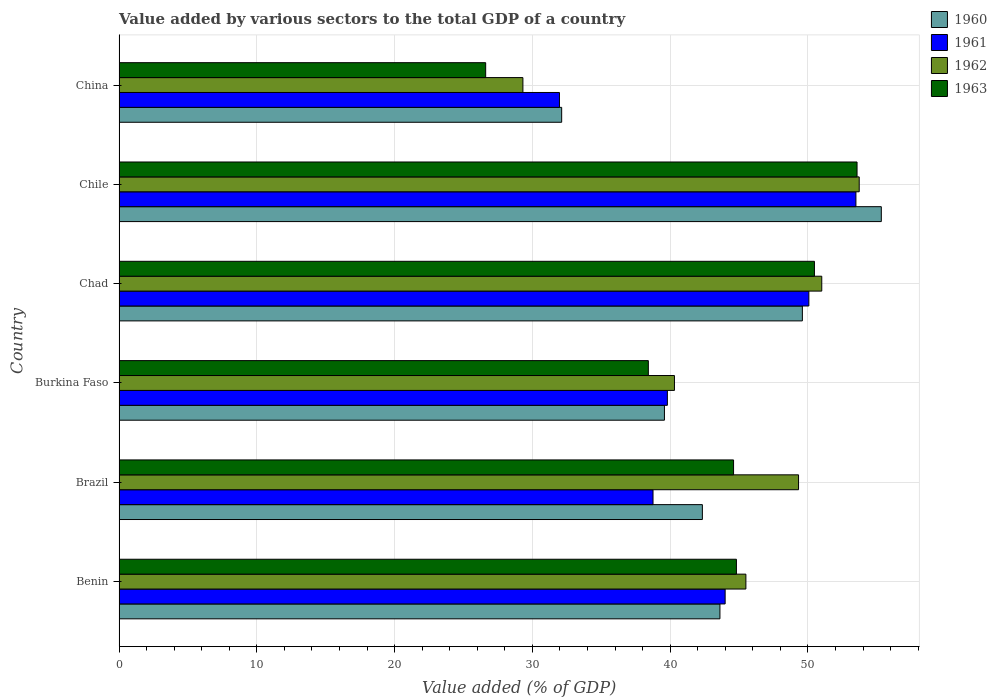How many groups of bars are there?
Keep it short and to the point. 6. Are the number of bars per tick equal to the number of legend labels?
Offer a very short reply. Yes. Are the number of bars on each tick of the Y-axis equal?
Provide a succinct answer. Yes. How many bars are there on the 4th tick from the top?
Provide a short and direct response. 4. What is the value added by various sectors to the total GDP in 1962 in Chad?
Keep it short and to the point. 51.01. Across all countries, what is the maximum value added by various sectors to the total GDP in 1962?
Your answer should be compact. 53.72. Across all countries, what is the minimum value added by various sectors to the total GDP in 1963?
Your answer should be very brief. 26.61. In which country was the value added by various sectors to the total GDP in 1963 maximum?
Ensure brevity in your answer.  Chile. What is the total value added by various sectors to the total GDP in 1960 in the graph?
Offer a terse response. 262.6. What is the difference between the value added by various sectors to the total GDP in 1960 in Chad and that in Chile?
Provide a short and direct response. -5.73. What is the difference between the value added by various sectors to the total GDP in 1961 in Brazil and the value added by various sectors to the total GDP in 1963 in Benin?
Ensure brevity in your answer.  -6.05. What is the average value added by various sectors to the total GDP in 1963 per country?
Give a very brief answer. 43.08. What is the difference between the value added by various sectors to the total GDP in 1960 and value added by various sectors to the total GDP in 1961 in Benin?
Make the answer very short. -0.38. In how many countries, is the value added by various sectors to the total GDP in 1963 greater than 28 %?
Ensure brevity in your answer.  5. What is the ratio of the value added by various sectors to the total GDP in 1961 in Burkina Faso to that in Chile?
Keep it short and to the point. 0.74. Is the difference between the value added by various sectors to the total GDP in 1960 in Chad and China greater than the difference between the value added by various sectors to the total GDP in 1961 in Chad and China?
Provide a succinct answer. No. What is the difference between the highest and the second highest value added by various sectors to the total GDP in 1960?
Provide a succinct answer. 5.73. What is the difference between the highest and the lowest value added by various sectors to the total GDP in 1962?
Provide a succinct answer. 24.41. In how many countries, is the value added by various sectors to the total GDP in 1961 greater than the average value added by various sectors to the total GDP in 1961 taken over all countries?
Your answer should be compact. 3. Is it the case that in every country, the sum of the value added by various sectors to the total GDP in 1960 and value added by various sectors to the total GDP in 1963 is greater than the value added by various sectors to the total GDP in 1962?
Make the answer very short. Yes. How many bars are there?
Offer a very short reply. 24. Are all the bars in the graph horizontal?
Ensure brevity in your answer.  Yes. How many countries are there in the graph?
Make the answer very short. 6. What is the difference between two consecutive major ticks on the X-axis?
Offer a terse response. 10. Does the graph contain grids?
Offer a very short reply. Yes. Where does the legend appear in the graph?
Give a very brief answer. Top right. What is the title of the graph?
Give a very brief answer. Value added by various sectors to the total GDP of a country. Does "1999" appear as one of the legend labels in the graph?
Your answer should be very brief. No. What is the label or title of the X-axis?
Ensure brevity in your answer.  Value added (% of GDP). What is the label or title of the Y-axis?
Your answer should be very brief. Country. What is the Value added (% of GDP) of 1960 in Benin?
Make the answer very short. 43.62. What is the Value added (% of GDP) of 1961 in Benin?
Provide a short and direct response. 43.99. What is the Value added (% of GDP) of 1962 in Benin?
Provide a short and direct response. 45.5. What is the Value added (% of GDP) in 1963 in Benin?
Your answer should be compact. 44.81. What is the Value added (% of GDP) in 1960 in Brazil?
Keep it short and to the point. 42.34. What is the Value added (% of GDP) in 1961 in Brazil?
Offer a terse response. 38.76. What is the Value added (% of GDP) in 1962 in Brazil?
Offer a very short reply. 49.32. What is the Value added (% of GDP) in 1963 in Brazil?
Offer a very short reply. 44.6. What is the Value added (% of GDP) in 1960 in Burkina Faso?
Your answer should be compact. 39.59. What is the Value added (% of GDP) of 1961 in Burkina Faso?
Give a very brief answer. 39.8. What is the Value added (% of GDP) of 1962 in Burkina Faso?
Your answer should be very brief. 40.31. What is the Value added (% of GDP) in 1963 in Burkina Faso?
Your answer should be very brief. 38.42. What is the Value added (% of GDP) of 1960 in Chad?
Make the answer very short. 49.6. What is the Value added (% of GDP) of 1961 in Chad?
Your answer should be compact. 50.07. What is the Value added (% of GDP) of 1962 in Chad?
Your response must be concise. 51.01. What is the Value added (% of GDP) in 1963 in Chad?
Offer a very short reply. 50.47. What is the Value added (% of GDP) in 1960 in Chile?
Keep it short and to the point. 55.33. What is the Value added (% of GDP) in 1961 in Chile?
Make the answer very short. 53.49. What is the Value added (% of GDP) in 1962 in Chile?
Your answer should be very brief. 53.72. What is the Value added (% of GDP) of 1963 in Chile?
Your answer should be compact. 53.57. What is the Value added (% of GDP) of 1960 in China?
Offer a very short reply. 32.13. What is the Value added (% of GDP) in 1961 in China?
Your answer should be compact. 31.97. What is the Value added (% of GDP) of 1962 in China?
Your answer should be very brief. 29.31. What is the Value added (% of GDP) in 1963 in China?
Provide a short and direct response. 26.61. Across all countries, what is the maximum Value added (% of GDP) of 1960?
Keep it short and to the point. 55.33. Across all countries, what is the maximum Value added (% of GDP) of 1961?
Offer a terse response. 53.49. Across all countries, what is the maximum Value added (% of GDP) in 1962?
Your answer should be very brief. 53.72. Across all countries, what is the maximum Value added (% of GDP) in 1963?
Keep it short and to the point. 53.57. Across all countries, what is the minimum Value added (% of GDP) in 1960?
Your answer should be very brief. 32.13. Across all countries, what is the minimum Value added (% of GDP) of 1961?
Provide a short and direct response. 31.97. Across all countries, what is the minimum Value added (% of GDP) in 1962?
Your response must be concise. 29.31. Across all countries, what is the minimum Value added (% of GDP) in 1963?
Give a very brief answer. 26.61. What is the total Value added (% of GDP) in 1960 in the graph?
Your answer should be compact. 262.6. What is the total Value added (% of GDP) in 1961 in the graph?
Your response must be concise. 258.07. What is the total Value added (% of GDP) of 1962 in the graph?
Your answer should be compact. 269.18. What is the total Value added (% of GDP) in 1963 in the graph?
Your answer should be compact. 258.49. What is the difference between the Value added (% of GDP) in 1960 in Benin and that in Brazil?
Your answer should be compact. 1.27. What is the difference between the Value added (% of GDP) in 1961 in Benin and that in Brazil?
Ensure brevity in your answer.  5.23. What is the difference between the Value added (% of GDP) in 1962 in Benin and that in Brazil?
Your answer should be very brief. -3.82. What is the difference between the Value added (% of GDP) in 1963 in Benin and that in Brazil?
Your response must be concise. 0.21. What is the difference between the Value added (% of GDP) of 1960 in Benin and that in Burkina Faso?
Give a very brief answer. 4.03. What is the difference between the Value added (% of GDP) in 1961 in Benin and that in Burkina Faso?
Offer a very short reply. 4.19. What is the difference between the Value added (% of GDP) of 1962 in Benin and that in Burkina Faso?
Your answer should be compact. 5.19. What is the difference between the Value added (% of GDP) of 1963 in Benin and that in Burkina Faso?
Ensure brevity in your answer.  6.39. What is the difference between the Value added (% of GDP) in 1960 in Benin and that in Chad?
Offer a very short reply. -5.98. What is the difference between the Value added (% of GDP) of 1961 in Benin and that in Chad?
Provide a succinct answer. -6.08. What is the difference between the Value added (% of GDP) of 1962 in Benin and that in Chad?
Make the answer very short. -5.51. What is the difference between the Value added (% of GDP) of 1963 in Benin and that in Chad?
Your answer should be very brief. -5.66. What is the difference between the Value added (% of GDP) in 1960 in Benin and that in Chile?
Your response must be concise. -11.71. What is the difference between the Value added (% of GDP) of 1961 in Benin and that in Chile?
Your answer should be very brief. -9.49. What is the difference between the Value added (% of GDP) of 1962 in Benin and that in Chile?
Your answer should be compact. -8.22. What is the difference between the Value added (% of GDP) of 1963 in Benin and that in Chile?
Make the answer very short. -8.75. What is the difference between the Value added (% of GDP) in 1960 in Benin and that in China?
Ensure brevity in your answer.  11.49. What is the difference between the Value added (% of GDP) in 1961 in Benin and that in China?
Ensure brevity in your answer.  12.03. What is the difference between the Value added (% of GDP) of 1962 in Benin and that in China?
Provide a short and direct response. 16.19. What is the difference between the Value added (% of GDP) of 1963 in Benin and that in China?
Ensure brevity in your answer.  18.2. What is the difference between the Value added (% of GDP) of 1960 in Brazil and that in Burkina Faso?
Ensure brevity in your answer.  2.75. What is the difference between the Value added (% of GDP) in 1961 in Brazil and that in Burkina Faso?
Keep it short and to the point. -1.04. What is the difference between the Value added (% of GDP) in 1962 in Brazil and that in Burkina Faso?
Keep it short and to the point. 9.01. What is the difference between the Value added (% of GDP) in 1963 in Brazil and that in Burkina Faso?
Your answer should be compact. 6.19. What is the difference between the Value added (% of GDP) of 1960 in Brazil and that in Chad?
Your answer should be very brief. -7.26. What is the difference between the Value added (% of GDP) in 1961 in Brazil and that in Chad?
Ensure brevity in your answer.  -11.31. What is the difference between the Value added (% of GDP) in 1962 in Brazil and that in Chad?
Offer a very short reply. -1.69. What is the difference between the Value added (% of GDP) in 1963 in Brazil and that in Chad?
Offer a terse response. -5.87. What is the difference between the Value added (% of GDP) of 1960 in Brazil and that in Chile?
Your response must be concise. -12.99. What is the difference between the Value added (% of GDP) of 1961 in Brazil and that in Chile?
Your answer should be very brief. -14.73. What is the difference between the Value added (% of GDP) of 1962 in Brazil and that in Chile?
Keep it short and to the point. -4.4. What is the difference between the Value added (% of GDP) in 1963 in Brazil and that in Chile?
Your answer should be very brief. -8.96. What is the difference between the Value added (% of GDP) in 1960 in Brazil and that in China?
Ensure brevity in your answer.  10.21. What is the difference between the Value added (% of GDP) of 1961 in Brazil and that in China?
Your answer should be very brief. 6.79. What is the difference between the Value added (% of GDP) in 1962 in Brazil and that in China?
Ensure brevity in your answer.  20.01. What is the difference between the Value added (% of GDP) in 1963 in Brazil and that in China?
Make the answer very short. 17.99. What is the difference between the Value added (% of GDP) of 1960 in Burkina Faso and that in Chad?
Provide a succinct answer. -10.01. What is the difference between the Value added (% of GDP) of 1961 in Burkina Faso and that in Chad?
Give a very brief answer. -10.27. What is the difference between the Value added (% of GDP) in 1962 in Burkina Faso and that in Chad?
Offer a very short reply. -10.69. What is the difference between the Value added (% of GDP) in 1963 in Burkina Faso and that in Chad?
Offer a very short reply. -12.06. What is the difference between the Value added (% of GDP) of 1960 in Burkina Faso and that in Chile?
Your answer should be very brief. -15.74. What is the difference between the Value added (% of GDP) in 1961 in Burkina Faso and that in Chile?
Your response must be concise. -13.69. What is the difference between the Value added (% of GDP) in 1962 in Burkina Faso and that in Chile?
Give a very brief answer. -13.41. What is the difference between the Value added (% of GDP) of 1963 in Burkina Faso and that in Chile?
Ensure brevity in your answer.  -15.15. What is the difference between the Value added (% of GDP) in 1960 in Burkina Faso and that in China?
Give a very brief answer. 7.46. What is the difference between the Value added (% of GDP) in 1961 in Burkina Faso and that in China?
Provide a short and direct response. 7.83. What is the difference between the Value added (% of GDP) in 1962 in Burkina Faso and that in China?
Provide a short and direct response. 11. What is the difference between the Value added (% of GDP) of 1963 in Burkina Faso and that in China?
Provide a succinct answer. 11.81. What is the difference between the Value added (% of GDP) in 1960 in Chad and that in Chile?
Your answer should be compact. -5.73. What is the difference between the Value added (% of GDP) in 1961 in Chad and that in Chile?
Your response must be concise. -3.42. What is the difference between the Value added (% of GDP) in 1962 in Chad and that in Chile?
Ensure brevity in your answer.  -2.72. What is the difference between the Value added (% of GDP) in 1963 in Chad and that in Chile?
Your response must be concise. -3.09. What is the difference between the Value added (% of GDP) of 1960 in Chad and that in China?
Your answer should be compact. 17.47. What is the difference between the Value added (% of GDP) in 1961 in Chad and that in China?
Make the answer very short. 18.1. What is the difference between the Value added (% of GDP) in 1962 in Chad and that in China?
Give a very brief answer. 21.69. What is the difference between the Value added (% of GDP) in 1963 in Chad and that in China?
Make the answer very short. 23.86. What is the difference between the Value added (% of GDP) in 1960 in Chile and that in China?
Your response must be concise. 23.2. What is the difference between the Value added (% of GDP) of 1961 in Chile and that in China?
Your answer should be very brief. 21.52. What is the difference between the Value added (% of GDP) of 1962 in Chile and that in China?
Make the answer very short. 24.41. What is the difference between the Value added (% of GDP) of 1963 in Chile and that in China?
Ensure brevity in your answer.  26.96. What is the difference between the Value added (% of GDP) of 1960 in Benin and the Value added (% of GDP) of 1961 in Brazil?
Provide a succinct answer. 4.86. What is the difference between the Value added (% of GDP) in 1960 in Benin and the Value added (% of GDP) in 1962 in Brazil?
Your response must be concise. -5.71. What is the difference between the Value added (% of GDP) in 1960 in Benin and the Value added (% of GDP) in 1963 in Brazil?
Ensure brevity in your answer.  -0.99. What is the difference between the Value added (% of GDP) in 1961 in Benin and the Value added (% of GDP) in 1962 in Brazil?
Keep it short and to the point. -5.33. What is the difference between the Value added (% of GDP) of 1961 in Benin and the Value added (% of GDP) of 1963 in Brazil?
Your answer should be very brief. -0.61. What is the difference between the Value added (% of GDP) of 1962 in Benin and the Value added (% of GDP) of 1963 in Brazil?
Provide a short and direct response. 0.89. What is the difference between the Value added (% of GDP) in 1960 in Benin and the Value added (% of GDP) in 1961 in Burkina Faso?
Your answer should be compact. 3.82. What is the difference between the Value added (% of GDP) of 1960 in Benin and the Value added (% of GDP) of 1962 in Burkina Faso?
Keep it short and to the point. 3.3. What is the difference between the Value added (% of GDP) of 1960 in Benin and the Value added (% of GDP) of 1963 in Burkina Faso?
Give a very brief answer. 5.2. What is the difference between the Value added (% of GDP) of 1961 in Benin and the Value added (% of GDP) of 1962 in Burkina Faso?
Provide a succinct answer. 3.68. What is the difference between the Value added (% of GDP) of 1961 in Benin and the Value added (% of GDP) of 1963 in Burkina Faso?
Keep it short and to the point. 5.57. What is the difference between the Value added (% of GDP) of 1962 in Benin and the Value added (% of GDP) of 1963 in Burkina Faso?
Ensure brevity in your answer.  7.08. What is the difference between the Value added (% of GDP) of 1960 in Benin and the Value added (% of GDP) of 1961 in Chad?
Your response must be concise. -6.45. What is the difference between the Value added (% of GDP) of 1960 in Benin and the Value added (% of GDP) of 1962 in Chad?
Provide a short and direct response. -7.39. What is the difference between the Value added (% of GDP) of 1960 in Benin and the Value added (% of GDP) of 1963 in Chad?
Your answer should be very brief. -6.86. What is the difference between the Value added (% of GDP) of 1961 in Benin and the Value added (% of GDP) of 1962 in Chad?
Your answer should be compact. -7.01. What is the difference between the Value added (% of GDP) of 1961 in Benin and the Value added (% of GDP) of 1963 in Chad?
Keep it short and to the point. -6.48. What is the difference between the Value added (% of GDP) in 1962 in Benin and the Value added (% of GDP) in 1963 in Chad?
Ensure brevity in your answer.  -4.98. What is the difference between the Value added (% of GDP) of 1960 in Benin and the Value added (% of GDP) of 1961 in Chile?
Make the answer very short. -9.87. What is the difference between the Value added (% of GDP) of 1960 in Benin and the Value added (% of GDP) of 1962 in Chile?
Keep it short and to the point. -10.11. What is the difference between the Value added (% of GDP) in 1960 in Benin and the Value added (% of GDP) in 1963 in Chile?
Offer a very short reply. -9.95. What is the difference between the Value added (% of GDP) of 1961 in Benin and the Value added (% of GDP) of 1962 in Chile?
Your answer should be compact. -9.73. What is the difference between the Value added (% of GDP) of 1961 in Benin and the Value added (% of GDP) of 1963 in Chile?
Your response must be concise. -9.57. What is the difference between the Value added (% of GDP) in 1962 in Benin and the Value added (% of GDP) in 1963 in Chile?
Keep it short and to the point. -8.07. What is the difference between the Value added (% of GDP) of 1960 in Benin and the Value added (% of GDP) of 1961 in China?
Your response must be concise. 11.65. What is the difference between the Value added (% of GDP) of 1960 in Benin and the Value added (% of GDP) of 1962 in China?
Give a very brief answer. 14.3. What is the difference between the Value added (% of GDP) in 1960 in Benin and the Value added (% of GDP) in 1963 in China?
Give a very brief answer. 17. What is the difference between the Value added (% of GDP) in 1961 in Benin and the Value added (% of GDP) in 1962 in China?
Your response must be concise. 14.68. What is the difference between the Value added (% of GDP) of 1961 in Benin and the Value added (% of GDP) of 1963 in China?
Your response must be concise. 17.38. What is the difference between the Value added (% of GDP) in 1962 in Benin and the Value added (% of GDP) in 1963 in China?
Your answer should be compact. 18.89. What is the difference between the Value added (% of GDP) of 1960 in Brazil and the Value added (% of GDP) of 1961 in Burkina Faso?
Your response must be concise. 2.54. What is the difference between the Value added (% of GDP) in 1960 in Brazil and the Value added (% of GDP) in 1962 in Burkina Faso?
Make the answer very short. 2.03. What is the difference between the Value added (% of GDP) in 1960 in Brazil and the Value added (% of GDP) in 1963 in Burkina Faso?
Give a very brief answer. 3.92. What is the difference between the Value added (% of GDP) in 1961 in Brazil and the Value added (% of GDP) in 1962 in Burkina Faso?
Your response must be concise. -1.55. What is the difference between the Value added (% of GDP) of 1961 in Brazil and the Value added (% of GDP) of 1963 in Burkina Faso?
Ensure brevity in your answer.  0.34. What is the difference between the Value added (% of GDP) of 1962 in Brazil and the Value added (% of GDP) of 1963 in Burkina Faso?
Keep it short and to the point. 10.9. What is the difference between the Value added (% of GDP) in 1960 in Brazil and the Value added (% of GDP) in 1961 in Chad?
Ensure brevity in your answer.  -7.73. What is the difference between the Value added (% of GDP) of 1960 in Brazil and the Value added (% of GDP) of 1962 in Chad?
Give a very brief answer. -8.67. What is the difference between the Value added (% of GDP) in 1960 in Brazil and the Value added (% of GDP) in 1963 in Chad?
Ensure brevity in your answer.  -8.13. What is the difference between the Value added (% of GDP) in 1961 in Brazil and the Value added (% of GDP) in 1962 in Chad?
Your answer should be compact. -12.25. What is the difference between the Value added (% of GDP) in 1961 in Brazil and the Value added (% of GDP) in 1963 in Chad?
Give a very brief answer. -11.72. What is the difference between the Value added (% of GDP) of 1962 in Brazil and the Value added (% of GDP) of 1963 in Chad?
Your response must be concise. -1.15. What is the difference between the Value added (% of GDP) in 1960 in Brazil and the Value added (% of GDP) in 1961 in Chile?
Your response must be concise. -11.14. What is the difference between the Value added (% of GDP) of 1960 in Brazil and the Value added (% of GDP) of 1962 in Chile?
Provide a short and direct response. -11.38. What is the difference between the Value added (% of GDP) of 1960 in Brazil and the Value added (% of GDP) of 1963 in Chile?
Give a very brief answer. -11.23. What is the difference between the Value added (% of GDP) in 1961 in Brazil and the Value added (% of GDP) in 1962 in Chile?
Your answer should be compact. -14.97. What is the difference between the Value added (% of GDP) in 1961 in Brazil and the Value added (% of GDP) in 1963 in Chile?
Your answer should be compact. -14.81. What is the difference between the Value added (% of GDP) in 1962 in Brazil and the Value added (% of GDP) in 1963 in Chile?
Your answer should be compact. -4.25. What is the difference between the Value added (% of GDP) in 1960 in Brazil and the Value added (% of GDP) in 1961 in China?
Your response must be concise. 10.37. What is the difference between the Value added (% of GDP) in 1960 in Brazil and the Value added (% of GDP) in 1962 in China?
Offer a very short reply. 13.03. What is the difference between the Value added (% of GDP) of 1960 in Brazil and the Value added (% of GDP) of 1963 in China?
Keep it short and to the point. 15.73. What is the difference between the Value added (% of GDP) of 1961 in Brazil and the Value added (% of GDP) of 1962 in China?
Ensure brevity in your answer.  9.44. What is the difference between the Value added (% of GDP) of 1961 in Brazil and the Value added (% of GDP) of 1963 in China?
Provide a succinct answer. 12.15. What is the difference between the Value added (% of GDP) of 1962 in Brazil and the Value added (% of GDP) of 1963 in China?
Provide a succinct answer. 22.71. What is the difference between the Value added (% of GDP) of 1960 in Burkina Faso and the Value added (% of GDP) of 1961 in Chad?
Your answer should be compact. -10.48. What is the difference between the Value added (% of GDP) in 1960 in Burkina Faso and the Value added (% of GDP) in 1962 in Chad?
Keep it short and to the point. -11.42. What is the difference between the Value added (% of GDP) in 1960 in Burkina Faso and the Value added (% of GDP) in 1963 in Chad?
Give a very brief answer. -10.89. What is the difference between the Value added (% of GDP) of 1961 in Burkina Faso and the Value added (% of GDP) of 1962 in Chad?
Offer a terse response. -11.21. What is the difference between the Value added (% of GDP) of 1961 in Burkina Faso and the Value added (% of GDP) of 1963 in Chad?
Your answer should be very brief. -10.68. What is the difference between the Value added (% of GDP) in 1962 in Burkina Faso and the Value added (% of GDP) in 1963 in Chad?
Offer a terse response. -10.16. What is the difference between the Value added (% of GDP) in 1960 in Burkina Faso and the Value added (% of GDP) in 1961 in Chile?
Give a very brief answer. -13.9. What is the difference between the Value added (% of GDP) in 1960 in Burkina Faso and the Value added (% of GDP) in 1962 in Chile?
Provide a succinct answer. -14.14. What is the difference between the Value added (% of GDP) of 1960 in Burkina Faso and the Value added (% of GDP) of 1963 in Chile?
Your answer should be compact. -13.98. What is the difference between the Value added (% of GDP) of 1961 in Burkina Faso and the Value added (% of GDP) of 1962 in Chile?
Offer a very short reply. -13.92. What is the difference between the Value added (% of GDP) of 1961 in Burkina Faso and the Value added (% of GDP) of 1963 in Chile?
Keep it short and to the point. -13.77. What is the difference between the Value added (% of GDP) of 1962 in Burkina Faso and the Value added (% of GDP) of 1963 in Chile?
Offer a terse response. -13.25. What is the difference between the Value added (% of GDP) of 1960 in Burkina Faso and the Value added (% of GDP) of 1961 in China?
Keep it short and to the point. 7.62. What is the difference between the Value added (% of GDP) of 1960 in Burkina Faso and the Value added (% of GDP) of 1962 in China?
Your answer should be compact. 10.27. What is the difference between the Value added (% of GDP) in 1960 in Burkina Faso and the Value added (% of GDP) in 1963 in China?
Provide a succinct answer. 12.97. What is the difference between the Value added (% of GDP) in 1961 in Burkina Faso and the Value added (% of GDP) in 1962 in China?
Your answer should be very brief. 10.49. What is the difference between the Value added (% of GDP) in 1961 in Burkina Faso and the Value added (% of GDP) in 1963 in China?
Offer a very short reply. 13.19. What is the difference between the Value added (% of GDP) of 1962 in Burkina Faso and the Value added (% of GDP) of 1963 in China?
Provide a succinct answer. 13.7. What is the difference between the Value added (% of GDP) in 1960 in Chad and the Value added (% of GDP) in 1961 in Chile?
Your answer should be compact. -3.89. What is the difference between the Value added (% of GDP) in 1960 in Chad and the Value added (% of GDP) in 1962 in Chile?
Provide a succinct answer. -4.13. What is the difference between the Value added (% of GDP) in 1960 in Chad and the Value added (% of GDP) in 1963 in Chile?
Keep it short and to the point. -3.97. What is the difference between the Value added (% of GDP) of 1961 in Chad and the Value added (% of GDP) of 1962 in Chile?
Your answer should be compact. -3.66. What is the difference between the Value added (% of GDP) of 1961 in Chad and the Value added (% of GDP) of 1963 in Chile?
Ensure brevity in your answer.  -3.5. What is the difference between the Value added (% of GDP) in 1962 in Chad and the Value added (% of GDP) in 1963 in Chile?
Ensure brevity in your answer.  -2.56. What is the difference between the Value added (% of GDP) in 1960 in Chad and the Value added (% of GDP) in 1961 in China?
Your answer should be compact. 17.63. What is the difference between the Value added (% of GDP) of 1960 in Chad and the Value added (% of GDP) of 1962 in China?
Offer a terse response. 20.29. What is the difference between the Value added (% of GDP) in 1960 in Chad and the Value added (% of GDP) in 1963 in China?
Your answer should be compact. 22.99. What is the difference between the Value added (% of GDP) in 1961 in Chad and the Value added (% of GDP) in 1962 in China?
Offer a very short reply. 20.76. What is the difference between the Value added (% of GDP) in 1961 in Chad and the Value added (% of GDP) in 1963 in China?
Keep it short and to the point. 23.46. What is the difference between the Value added (% of GDP) of 1962 in Chad and the Value added (% of GDP) of 1963 in China?
Your answer should be compact. 24.39. What is the difference between the Value added (% of GDP) of 1960 in Chile and the Value added (% of GDP) of 1961 in China?
Make the answer very short. 23.36. What is the difference between the Value added (% of GDP) of 1960 in Chile and the Value added (% of GDP) of 1962 in China?
Keep it short and to the point. 26.02. What is the difference between the Value added (% of GDP) in 1960 in Chile and the Value added (% of GDP) in 1963 in China?
Keep it short and to the point. 28.72. What is the difference between the Value added (% of GDP) in 1961 in Chile and the Value added (% of GDP) in 1962 in China?
Give a very brief answer. 24.17. What is the difference between the Value added (% of GDP) in 1961 in Chile and the Value added (% of GDP) in 1963 in China?
Ensure brevity in your answer.  26.87. What is the difference between the Value added (% of GDP) in 1962 in Chile and the Value added (% of GDP) in 1963 in China?
Give a very brief answer. 27.11. What is the average Value added (% of GDP) in 1960 per country?
Your answer should be compact. 43.77. What is the average Value added (% of GDP) of 1961 per country?
Your answer should be compact. 43.01. What is the average Value added (% of GDP) in 1962 per country?
Make the answer very short. 44.86. What is the average Value added (% of GDP) in 1963 per country?
Your answer should be compact. 43.08. What is the difference between the Value added (% of GDP) of 1960 and Value added (% of GDP) of 1961 in Benin?
Keep it short and to the point. -0.38. What is the difference between the Value added (% of GDP) in 1960 and Value added (% of GDP) in 1962 in Benin?
Make the answer very short. -1.88. What is the difference between the Value added (% of GDP) in 1960 and Value added (% of GDP) in 1963 in Benin?
Provide a short and direct response. -1.2. What is the difference between the Value added (% of GDP) in 1961 and Value added (% of GDP) in 1962 in Benin?
Provide a short and direct response. -1.51. What is the difference between the Value added (% of GDP) in 1961 and Value added (% of GDP) in 1963 in Benin?
Ensure brevity in your answer.  -0.82. What is the difference between the Value added (% of GDP) in 1962 and Value added (% of GDP) in 1963 in Benin?
Offer a terse response. 0.69. What is the difference between the Value added (% of GDP) of 1960 and Value added (% of GDP) of 1961 in Brazil?
Offer a very short reply. 3.58. What is the difference between the Value added (% of GDP) in 1960 and Value added (% of GDP) in 1962 in Brazil?
Your answer should be compact. -6.98. What is the difference between the Value added (% of GDP) of 1960 and Value added (% of GDP) of 1963 in Brazil?
Offer a very short reply. -2.26. What is the difference between the Value added (% of GDP) of 1961 and Value added (% of GDP) of 1962 in Brazil?
Make the answer very short. -10.56. What is the difference between the Value added (% of GDP) of 1961 and Value added (% of GDP) of 1963 in Brazil?
Your response must be concise. -5.85. What is the difference between the Value added (% of GDP) of 1962 and Value added (% of GDP) of 1963 in Brazil?
Keep it short and to the point. 4.72. What is the difference between the Value added (% of GDP) of 1960 and Value added (% of GDP) of 1961 in Burkina Faso?
Ensure brevity in your answer.  -0.21. What is the difference between the Value added (% of GDP) in 1960 and Value added (% of GDP) in 1962 in Burkina Faso?
Your answer should be compact. -0.73. What is the difference between the Value added (% of GDP) in 1960 and Value added (% of GDP) in 1963 in Burkina Faso?
Give a very brief answer. 1.17. What is the difference between the Value added (% of GDP) in 1961 and Value added (% of GDP) in 1962 in Burkina Faso?
Offer a terse response. -0.51. What is the difference between the Value added (% of GDP) in 1961 and Value added (% of GDP) in 1963 in Burkina Faso?
Your response must be concise. 1.38. What is the difference between the Value added (% of GDP) in 1962 and Value added (% of GDP) in 1963 in Burkina Faso?
Make the answer very short. 1.89. What is the difference between the Value added (% of GDP) in 1960 and Value added (% of GDP) in 1961 in Chad?
Keep it short and to the point. -0.47. What is the difference between the Value added (% of GDP) in 1960 and Value added (% of GDP) in 1962 in Chad?
Your answer should be compact. -1.41. What is the difference between the Value added (% of GDP) in 1960 and Value added (% of GDP) in 1963 in Chad?
Ensure brevity in your answer.  -0.88. What is the difference between the Value added (% of GDP) in 1961 and Value added (% of GDP) in 1962 in Chad?
Your answer should be compact. -0.94. What is the difference between the Value added (% of GDP) of 1961 and Value added (% of GDP) of 1963 in Chad?
Offer a terse response. -0.41. What is the difference between the Value added (% of GDP) of 1962 and Value added (% of GDP) of 1963 in Chad?
Your answer should be very brief. 0.53. What is the difference between the Value added (% of GDP) in 1960 and Value added (% of GDP) in 1961 in Chile?
Make the answer very short. 1.84. What is the difference between the Value added (% of GDP) of 1960 and Value added (% of GDP) of 1962 in Chile?
Provide a short and direct response. 1.6. What is the difference between the Value added (% of GDP) of 1960 and Value added (% of GDP) of 1963 in Chile?
Give a very brief answer. 1.76. What is the difference between the Value added (% of GDP) of 1961 and Value added (% of GDP) of 1962 in Chile?
Provide a succinct answer. -0.24. What is the difference between the Value added (% of GDP) in 1961 and Value added (% of GDP) in 1963 in Chile?
Provide a short and direct response. -0.08. What is the difference between the Value added (% of GDP) of 1962 and Value added (% of GDP) of 1963 in Chile?
Offer a terse response. 0.16. What is the difference between the Value added (% of GDP) in 1960 and Value added (% of GDP) in 1961 in China?
Offer a very short reply. 0.16. What is the difference between the Value added (% of GDP) of 1960 and Value added (% of GDP) of 1962 in China?
Offer a terse response. 2.81. What is the difference between the Value added (% of GDP) of 1960 and Value added (% of GDP) of 1963 in China?
Offer a terse response. 5.52. What is the difference between the Value added (% of GDP) of 1961 and Value added (% of GDP) of 1962 in China?
Make the answer very short. 2.65. What is the difference between the Value added (% of GDP) of 1961 and Value added (% of GDP) of 1963 in China?
Your answer should be very brief. 5.36. What is the difference between the Value added (% of GDP) in 1962 and Value added (% of GDP) in 1963 in China?
Make the answer very short. 2.7. What is the ratio of the Value added (% of GDP) of 1960 in Benin to that in Brazil?
Provide a succinct answer. 1.03. What is the ratio of the Value added (% of GDP) of 1961 in Benin to that in Brazil?
Keep it short and to the point. 1.14. What is the ratio of the Value added (% of GDP) in 1962 in Benin to that in Brazil?
Keep it short and to the point. 0.92. What is the ratio of the Value added (% of GDP) in 1960 in Benin to that in Burkina Faso?
Your response must be concise. 1.1. What is the ratio of the Value added (% of GDP) of 1961 in Benin to that in Burkina Faso?
Keep it short and to the point. 1.11. What is the ratio of the Value added (% of GDP) of 1962 in Benin to that in Burkina Faso?
Offer a terse response. 1.13. What is the ratio of the Value added (% of GDP) in 1963 in Benin to that in Burkina Faso?
Provide a short and direct response. 1.17. What is the ratio of the Value added (% of GDP) of 1960 in Benin to that in Chad?
Your answer should be compact. 0.88. What is the ratio of the Value added (% of GDP) of 1961 in Benin to that in Chad?
Offer a very short reply. 0.88. What is the ratio of the Value added (% of GDP) in 1962 in Benin to that in Chad?
Your answer should be compact. 0.89. What is the ratio of the Value added (% of GDP) in 1963 in Benin to that in Chad?
Provide a succinct answer. 0.89. What is the ratio of the Value added (% of GDP) of 1960 in Benin to that in Chile?
Provide a short and direct response. 0.79. What is the ratio of the Value added (% of GDP) of 1961 in Benin to that in Chile?
Keep it short and to the point. 0.82. What is the ratio of the Value added (% of GDP) in 1962 in Benin to that in Chile?
Provide a short and direct response. 0.85. What is the ratio of the Value added (% of GDP) in 1963 in Benin to that in Chile?
Offer a terse response. 0.84. What is the ratio of the Value added (% of GDP) of 1960 in Benin to that in China?
Offer a terse response. 1.36. What is the ratio of the Value added (% of GDP) in 1961 in Benin to that in China?
Offer a terse response. 1.38. What is the ratio of the Value added (% of GDP) of 1962 in Benin to that in China?
Make the answer very short. 1.55. What is the ratio of the Value added (% of GDP) in 1963 in Benin to that in China?
Give a very brief answer. 1.68. What is the ratio of the Value added (% of GDP) of 1960 in Brazil to that in Burkina Faso?
Ensure brevity in your answer.  1.07. What is the ratio of the Value added (% of GDP) of 1961 in Brazil to that in Burkina Faso?
Provide a succinct answer. 0.97. What is the ratio of the Value added (% of GDP) in 1962 in Brazil to that in Burkina Faso?
Make the answer very short. 1.22. What is the ratio of the Value added (% of GDP) of 1963 in Brazil to that in Burkina Faso?
Provide a short and direct response. 1.16. What is the ratio of the Value added (% of GDP) in 1960 in Brazil to that in Chad?
Ensure brevity in your answer.  0.85. What is the ratio of the Value added (% of GDP) in 1961 in Brazil to that in Chad?
Offer a terse response. 0.77. What is the ratio of the Value added (% of GDP) in 1963 in Brazil to that in Chad?
Ensure brevity in your answer.  0.88. What is the ratio of the Value added (% of GDP) in 1960 in Brazil to that in Chile?
Ensure brevity in your answer.  0.77. What is the ratio of the Value added (% of GDP) in 1961 in Brazil to that in Chile?
Your answer should be very brief. 0.72. What is the ratio of the Value added (% of GDP) in 1962 in Brazil to that in Chile?
Make the answer very short. 0.92. What is the ratio of the Value added (% of GDP) in 1963 in Brazil to that in Chile?
Make the answer very short. 0.83. What is the ratio of the Value added (% of GDP) of 1960 in Brazil to that in China?
Offer a terse response. 1.32. What is the ratio of the Value added (% of GDP) of 1961 in Brazil to that in China?
Your answer should be compact. 1.21. What is the ratio of the Value added (% of GDP) of 1962 in Brazil to that in China?
Offer a terse response. 1.68. What is the ratio of the Value added (% of GDP) of 1963 in Brazil to that in China?
Provide a succinct answer. 1.68. What is the ratio of the Value added (% of GDP) of 1960 in Burkina Faso to that in Chad?
Keep it short and to the point. 0.8. What is the ratio of the Value added (% of GDP) of 1961 in Burkina Faso to that in Chad?
Provide a short and direct response. 0.79. What is the ratio of the Value added (% of GDP) in 1962 in Burkina Faso to that in Chad?
Give a very brief answer. 0.79. What is the ratio of the Value added (% of GDP) of 1963 in Burkina Faso to that in Chad?
Give a very brief answer. 0.76. What is the ratio of the Value added (% of GDP) in 1960 in Burkina Faso to that in Chile?
Keep it short and to the point. 0.72. What is the ratio of the Value added (% of GDP) in 1961 in Burkina Faso to that in Chile?
Your response must be concise. 0.74. What is the ratio of the Value added (% of GDP) of 1962 in Burkina Faso to that in Chile?
Ensure brevity in your answer.  0.75. What is the ratio of the Value added (% of GDP) in 1963 in Burkina Faso to that in Chile?
Provide a succinct answer. 0.72. What is the ratio of the Value added (% of GDP) in 1960 in Burkina Faso to that in China?
Your answer should be compact. 1.23. What is the ratio of the Value added (% of GDP) of 1961 in Burkina Faso to that in China?
Your answer should be compact. 1.25. What is the ratio of the Value added (% of GDP) in 1962 in Burkina Faso to that in China?
Give a very brief answer. 1.38. What is the ratio of the Value added (% of GDP) of 1963 in Burkina Faso to that in China?
Offer a very short reply. 1.44. What is the ratio of the Value added (% of GDP) of 1960 in Chad to that in Chile?
Ensure brevity in your answer.  0.9. What is the ratio of the Value added (% of GDP) in 1961 in Chad to that in Chile?
Provide a short and direct response. 0.94. What is the ratio of the Value added (% of GDP) in 1962 in Chad to that in Chile?
Give a very brief answer. 0.95. What is the ratio of the Value added (% of GDP) of 1963 in Chad to that in Chile?
Ensure brevity in your answer.  0.94. What is the ratio of the Value added (% of GDP) in 1960 in Chad to that in China?
Provide a succinct answer. 1.54. What is the ratio of the Value added (% of GDP) of 1961 in Chad to that in China?
Provide a succinct answer. 1.57. What is the ratio of the Value added (% of GDP) in 1962 in Chad to that in China?
Make the answer very short. 1.74. What is the ratio of the Value added (% of GDP) in 1963 in Chad to that in China?
Provide a short and direct response. 1.9. What is the ratio of the Value added (% of GDP) in 1960 in Chile to that in China?
Provide a short and direct response. 1.72. What is the ratio of the Value added (% of GDP) of 1961 in Chile to that in China?
Your answer should be very brief. 1.67. What is the ratio of the Value added (% of GDP) in 1962 in Chile to that in China?
Give a very brief answer. 1.83. What is the ratio of the Value added (% of GDP) of 1963 in Chile to that in China?
Provide a succinct answer. 2.01. What is the difference between the highest and the second highest Value added (% of GDP) of 1960?
Make the answer very short. 5.73. What is the difference between the highest and the second highest Value added (% of GDP) of 1961?
Offer a terse response. 3.42. What is the difference between the highest and the second highest Value added (% of GDP) of 1962?
Offer a terse response. 2.72. What is the difference between the highest and the second highest Value added (% of GDP) of 1963?
Offer a very short reply. 3.09. What is the difference between the highest and the lowest Value added (% of GDP) in 1960?
Your answer should be very brief. 23.2. What is the difference between the highest and the lowest Value added (% of GDP) of 1961?
Your answer should be compact. 21.52. What is the difference between the highest and the lowest Value added (% of GDP) of 1962?
Give a very brief answer. 24.41. What is the difference between the highest and the lowest Value added (% of GDP) in 1963?
Make the answer very short. 26.96. 